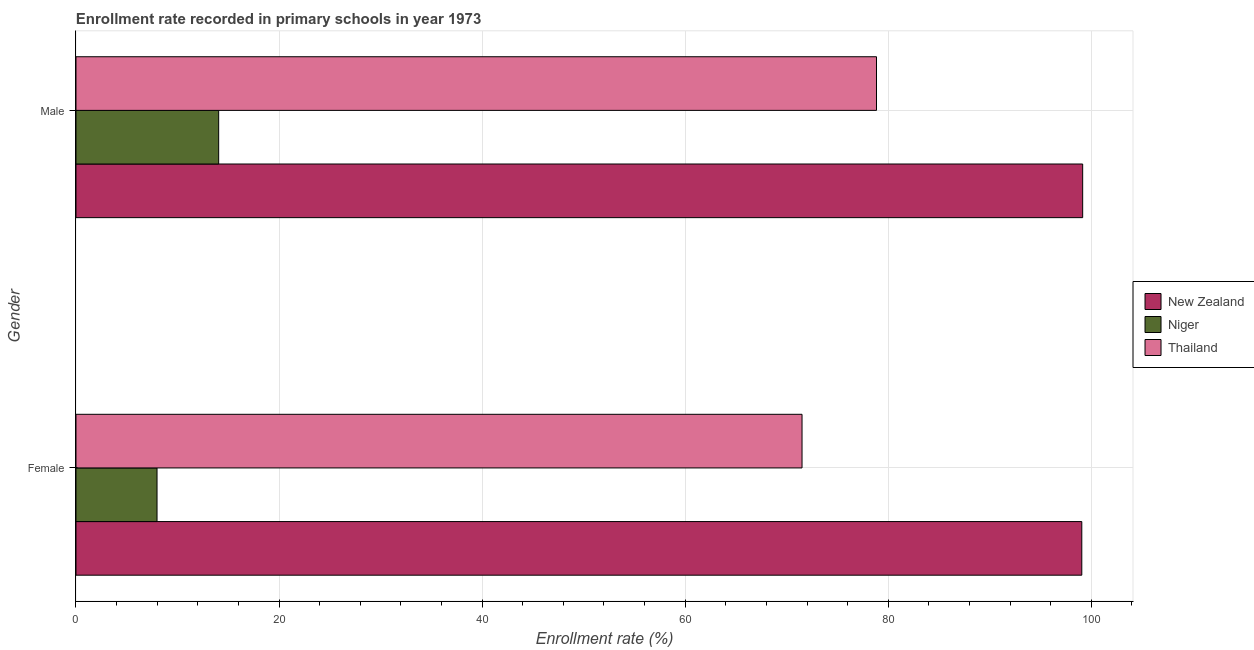How many different coloured bars are there?
Provide a succinct answer. 3. What is the label of the 2nd group of bars from the top?
Your answer should be compact. Female. What is the enrollment rate of female students in New Zealand?
Offer a terse response. 99.07. Across all countries, what is the maximum enrollment rate of female students?
Offer a terse response. 99.07. Across all countries, what is the minimum enrollment rate of male students?
Keep it short and to the point. 14.05. In which country was the enrollment rate of male students maximum?
Offer a terse response. New Zealand. In which country was the enrollment rate of male students minimum?
Provide a succinct answer. Niger. What is the total enrollment rate of female students in the graph?
Give a very brief answer. 178.56. What is the difference between the enrollment rate of male students in Niger and that in New Zealand?
Give a very brief answer. -85.1. What is the difference between the enrollment rate of female students in Niger and the enrollment rate of male students in New Zealand?
Make the answer very short. -91.17. What is the average enrollment rate of female students per country?
Provide a short and direct response. 59.52. What is the difference between the enrollment rate of male students and enrollment rate of female students in Thailand?
Keep it short and to the point. 7.33. In how many countries, is the enrollment rate of female students greater than 100 %?
Your answer should be very brief. 0. What is the ratio of the enrollment rate of male students in Niger to that in Thailand?
Provide a succinct answer. 0.18. Is the enrollment rate of male students in Thailand less than that in New Zealand?
Make the answer very short. Yes. What does the 1st bar from the top in Female represents?
Offer a terse response. Thailand. What does the 1st bar from the bottom in Female represents?
Offer a very short reply. New Zealand. How many bars are there?
Ensure brevity in your answer.  6. Are all the bars in the graph horizontal?
Keep it short and to the point. Yes. How many countries are there in the graph?
Offer a terse response. 3. What is the difference between two consecutive major ticks on the X-axis?
Provide a short and direct response. 20. Are the values on the major ticks of X-axis written in scientific E-notation?
Give a very brief answer. No. Does the graph contain any zero values?
Offer a terse response. No. Does the graph contain grids?
Your answer should be compact. Yes. How are the legend labels stacked?
Make the answer very short. Vertical. What is the title of the graph?
Your answer should be compact. Enrollment rate recorded in primary schools in year 1973. Does "Antigua and Barbuda" appear as one of the legend labels in the graph?
Provide a succinct answer. No. What is the label or title of the X-axis?
Offer a terse response. Enrollment rate (%). What is the Enrollment rate (%) in New Zealand in Female?
Offer a very short reply. 99.07. What is the Enrollment rate (%) of Niger in Female?
Provide a short and direct response. 7.98. What is the Enrollment rate (%) of Thailand in Female?
Provide a short and direct response. 71.51. What is the Enrollment rate (%) of New Zealand in Male?
Your answer should be very brief. 99.15. What is the Enrollment rate (%) in Niger in Male?
Keep it short and to the point. 14.05. What is the Enrollment rate (%) of Thailand in Male?
Make the answer very short. 78.85. Across all Gender, what is the maximum Enrollment rate (%) of New Zealand?
Ensure brevity in your answer.  99.15. Across all Gender, what is the maximum Enrollment rate (%) in Niger?
Your response must be concise. 14.05. Across all Gender, what is the maximum Enrollment rate (%) of Thailand?
Offer a terse response. 78.85. Across all Gender, what is the minimum Enrollment rate (%) of New Zealand?
Your response must be concise. 99.07. Across all Gender, what is the minimum Enrollment rate (%) of Niger?
Give a very brief answer. 7.98. Across all Gender, what is the minimum Enrollment rate (%) of Thailand?
Your response must be concise. 71.51. What is the total Enrollment rate (%) of New Zealand in the graph?
Ensure brevity in your answer.  198.22. What is the total Enrollment rate (%) of Niger in the graph?
Offer a very short reply. 22.03. What is the total Enrollment rate (%) of Thailand in the graph?
Your response must be concise. 150.36. What is the difference between the Enrollment rate (%) in New Zealand in Female and that in Male?
Make the answer very short. -0.09. What is the difference between the Enrollment rate (%) of Niger in Female and that in Male?
Keep it short and to the point. -6.07. What is the difference between the Enrollment rate (%) of Thailand in Female and that in Male?
Ensure brevity in your answer.  -7.33. What is the difference between the Enrollment rate (%) in New Zealand in Female and the Enrollment rate (%) in Niger in Male?
Provide a succinct answer. 85.01. What is the difference between the Enrollment rate (%) of New Zealand in Female and the Enrollment rate (%) of Thailand in Male?
Make the answer very short. 20.22. What is the difference between the Enrollment rate (%) of Niger in Female and the Enrollment rate (%) of Thailand in Male?
Give a very brief answer. -70.86. What is the average Enrollment rate (%) in New Zealand per Gender?
Your answer should be very brief. 99.11. What is the average Enrollment rate (%) in Niger per Gender?
Give a very brief answer. 11.02. What is the average Enrollment rate (%) of Thailand per Gender?
Offer a very short reply. 75.18. What is the difference between the Enrollment rate (%) in New Zealand and Enrollment rate (%) in Niger in Female?
Make the answer very short. 91.08. What is the difference between the Enrollment rate (%) of New Zealand and Enrollment rate (%) of Thailand in Female?
Keep it short and to the point. 27.56. What is the difference between the Enrollment rate (%) in Niger and Enrollment rate (%) in Thailand in Female?
Ensure brevity in your answer.  -63.53. What is the difference between the Enrollment rate (%) of New Zealand and Enrollment rate (%) of Niger in Male?
Offer a very short reply. 85.1. What is the difference between the Enrollment rate (%) in New Zealand and Enrollment rate (%) in Thailand in Male?
Provide a succinct answer. 20.31. What is the difference between the Enrollment rate (%) in Niger and Enrollment rate (%) in Thailand in Male?
Offer a very short reply. -64.79. What is the ratio of the Enrollment rate (%) in New Zealand in Female to that in Male?
Your answer should be compact. 1. What is the ratio of the Enrollment rate (%) in Niger in Female to that in Male?
Ensure brevity in your answer.  0.57. What is the ratio of the Enrollment rate (%) of Thailand in Female to that in Male?
Ensure brevity in your answer.  0.91. What is the difference between the highest and the second highest Enrollment rate (%) in New Zealand?
Make the answer very short. 0.09. What is the difference between the highest and the second highest Enrollment rate (%) in Niger?
Offer a terse response. 6.07. What is the difference between the highest and the second highest Enrollment rate (%) in Thailand?
Your answer should be compact. 7.33. What is the difference between the highest and the lowest Enrollment rate (%) in New Zealand?
Your answer should be very brief. 0.09. What is the difference between the highest and the lowest Enrollment rate (%) of Niger?
Ensure brevity in your answer.  6.07. What is the difference between the highest and the lowest Enrollment rate (%) of Thailand?
Give a very brief answer. 7.33. 